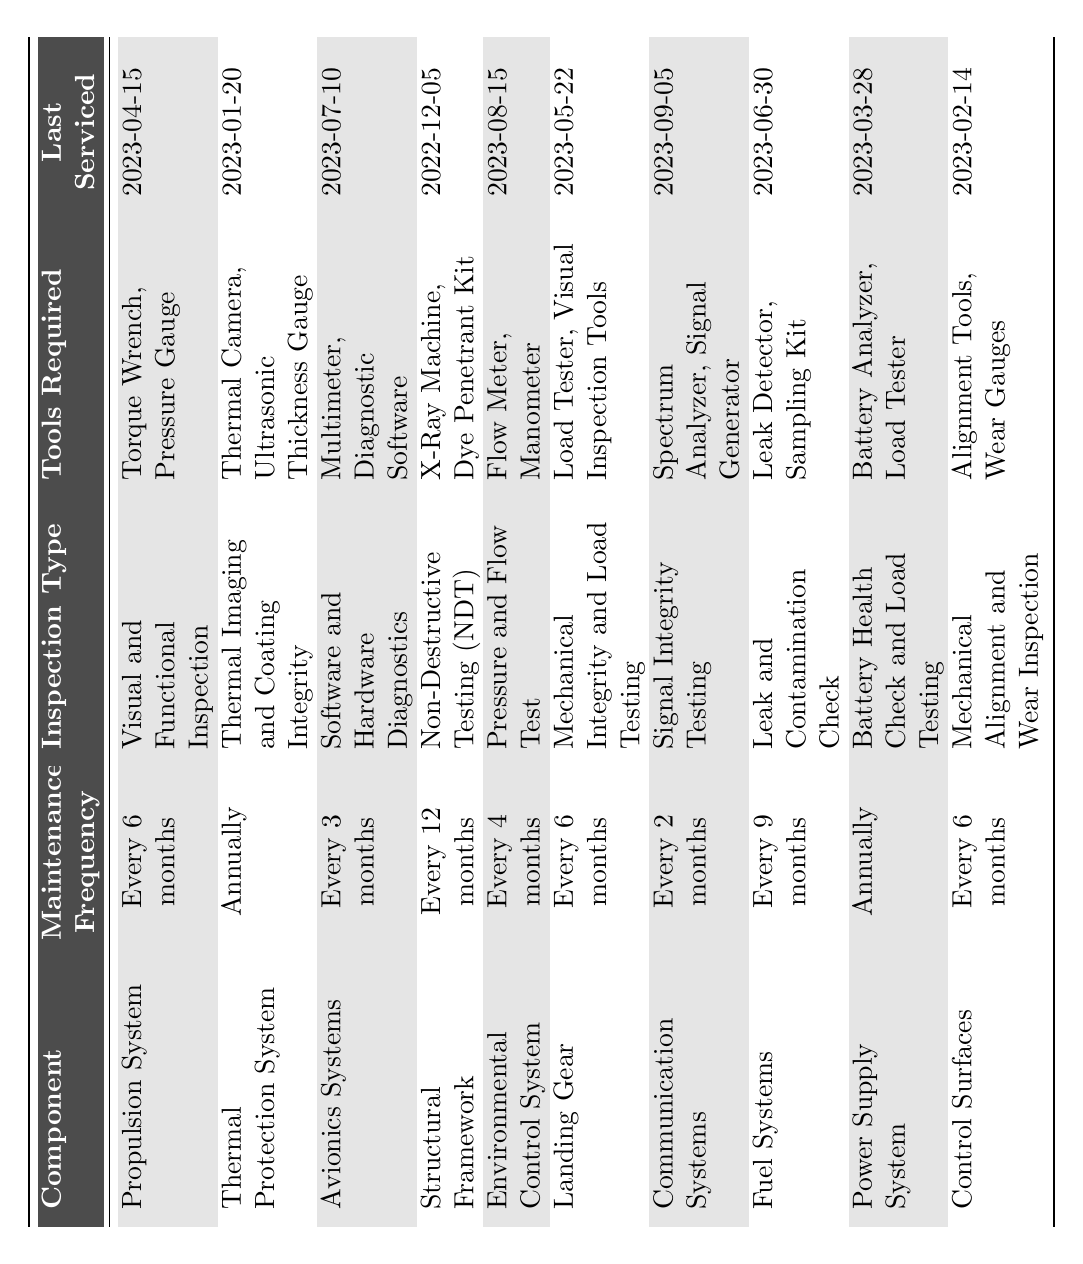What component requires maintenance every 2 months? The table shows that "Communication Systems" has a maintenance frequency of "Every 2 months."
Answer: Communication Systems What inspection type is performed for the Thermal Protection System? According to the table, the inspection type for the Thermal Protection System is "Thermal Imaging and Coating Integrity."
Answer: Thermal Imaging and Coating Integrity Which component was last serviced on 2023-08-15? Looking at the table, the "Environmental Control System" shows that it was last serviced on 2023-08-15.
Answer: Environmental Control System How many components require annual maintenance? The table lists the "Thermal Protection System" and "Power Supply System" as having an annual maintenance frequency; thus, there are 2 components.
Answer: 2 What is the average maintenance frequency in months for all components? The maintenance frequencies are: 6, 12, 3, 4, 6, 9, 2, and 1 (in months); thus, the average is (6 + 12 + 3 + 4 + 6 + 9 + 2 + 12) = 54 months, and dividing this by 8 components gives an average of 6.75 months.
Answer: 6.75 months Is the last serviced date for the Fuel Systems before or after 2023-06-30? The last serviced date for Fuel Systems is 2023-06-30, so it is neither before nor after, it is on that date.
Answer: On that date Which component has the longest maintenance frequency? The Structural Framework requires maintenance every 12 months, which is the longest frequency among all components.
Answer: Structural Framework What tools are required for the inspection of the Communication Systems? Based on the table, the tools required for Communication Systems inspection are "Spectrum Analyzer" and "Signal Generator."
Answer: Spectrum Analyzer, Signal Generator Which component has the most recent maintenance date? Looking at the "Last Serviced" dates, "Communication Systems" was last serviced on 2023-09-05, which is the most recent date.
Answer: Communication Systems How many components require visual inspection as part of their maintenance? "Propulsion System," "Landing Gear," and "Control Surfaces" all require visual inspection, totaling 3 components.
Answer: 3 What is the difference in maintenance frequency between the Environmental Control System and the Avionics Systems? The maintenance frequency for Environmental Control System is every 4 months, while Avionics Systems is every 3 months, so the difference is 1 month.
Answer: 1 month 